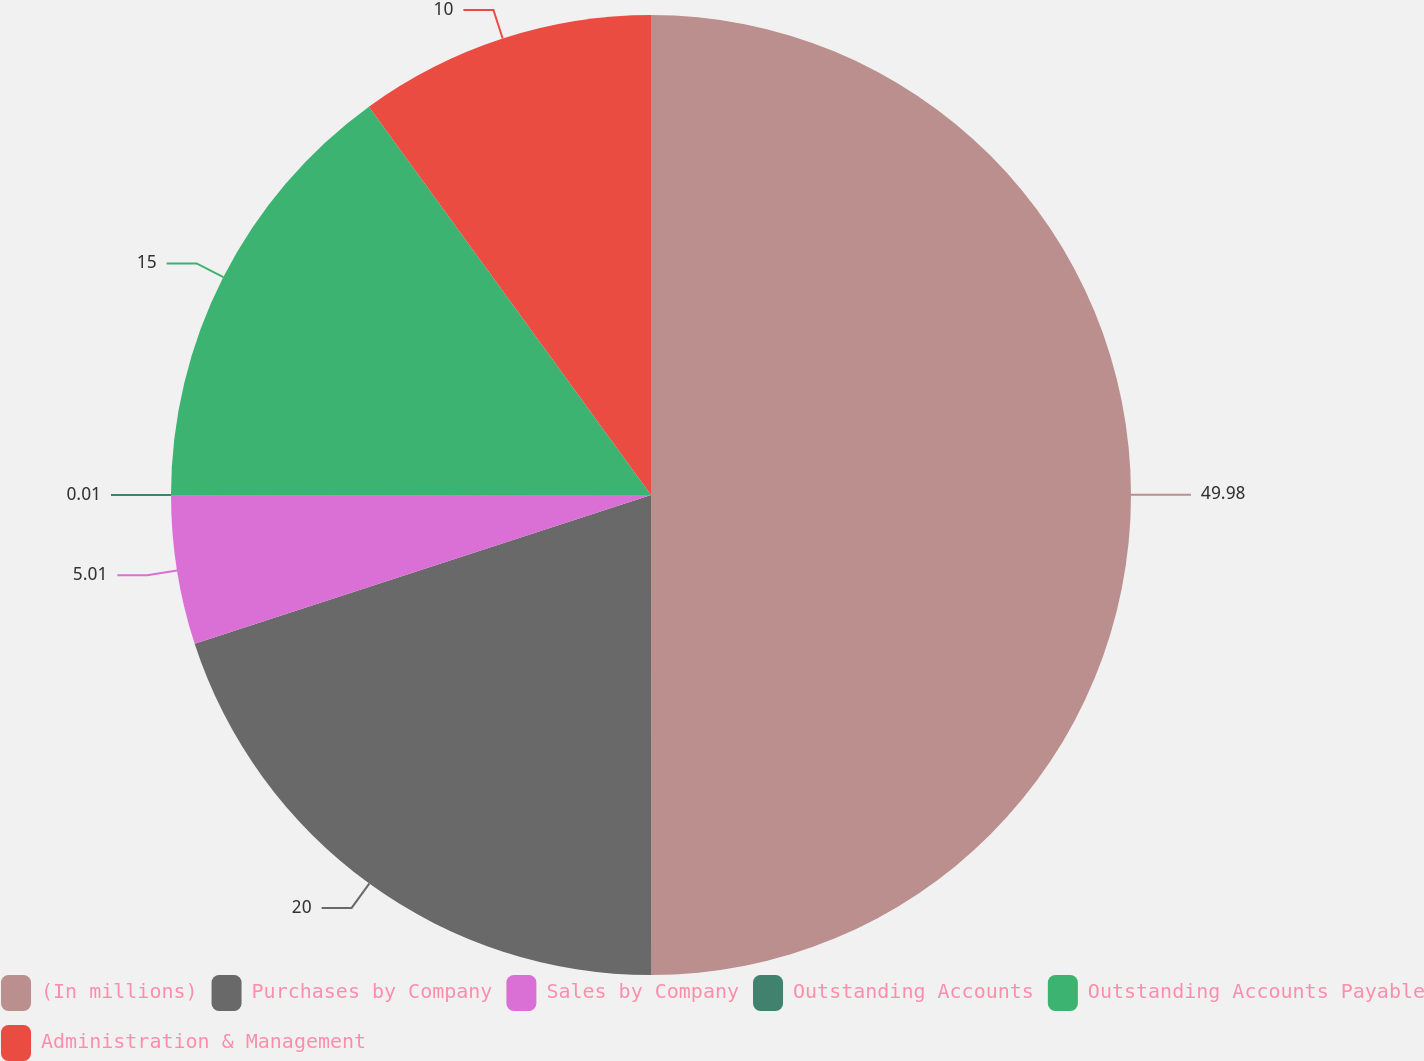Convert chart to OTSL. <chart><loc_0><loc_0><loc_500><loc_500><pie_chart><fcel>(In millions)<fcel>Purchases by Company<fcel>Sales by Company<fcel>Outstanding Accounts<fcel>Outstanding Accounts Payable<fcel>Administration & Management<nl><fcel>49.99%<fcel>20.0%<fcel>5.01%<fcel>0.01%<fcel>15.0%<fcel>10.0%<nl></chart> 